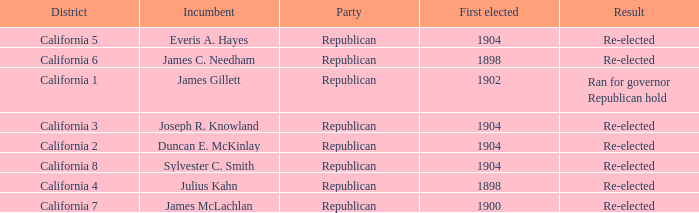Which District has a Result of Re-elected and a First Elected of 1898? California 4, California 6. 